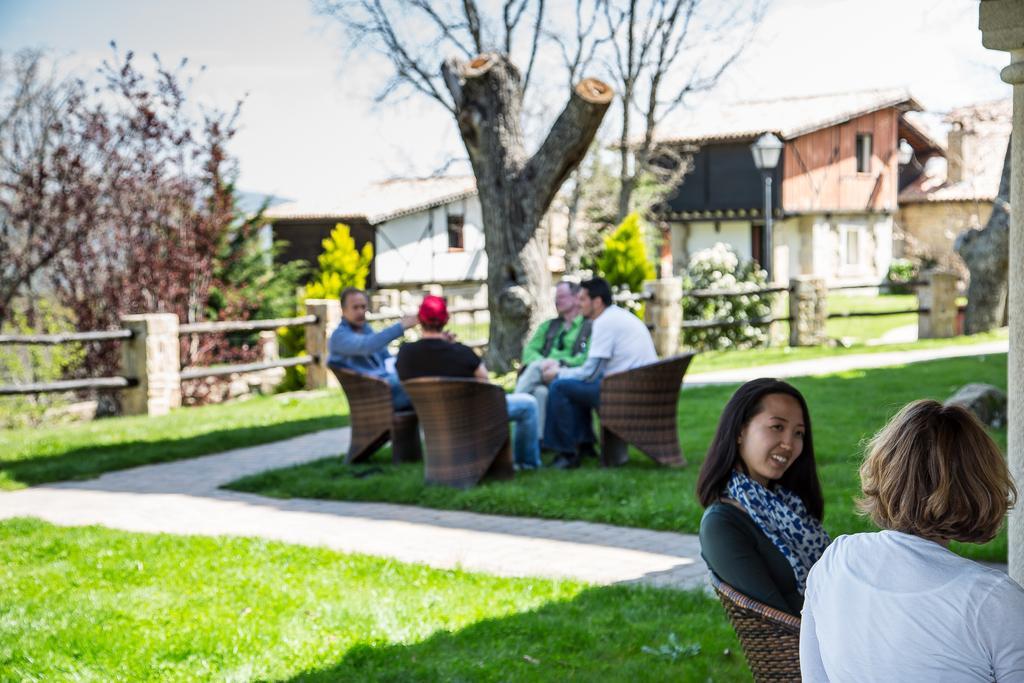Describe this image in one or two sentences. In this image there is a ground, on which there are few people sitting on chairs, trunk of trees visible, fence, light poles, trees, plants, houses visible ,at the top there is the sky. 